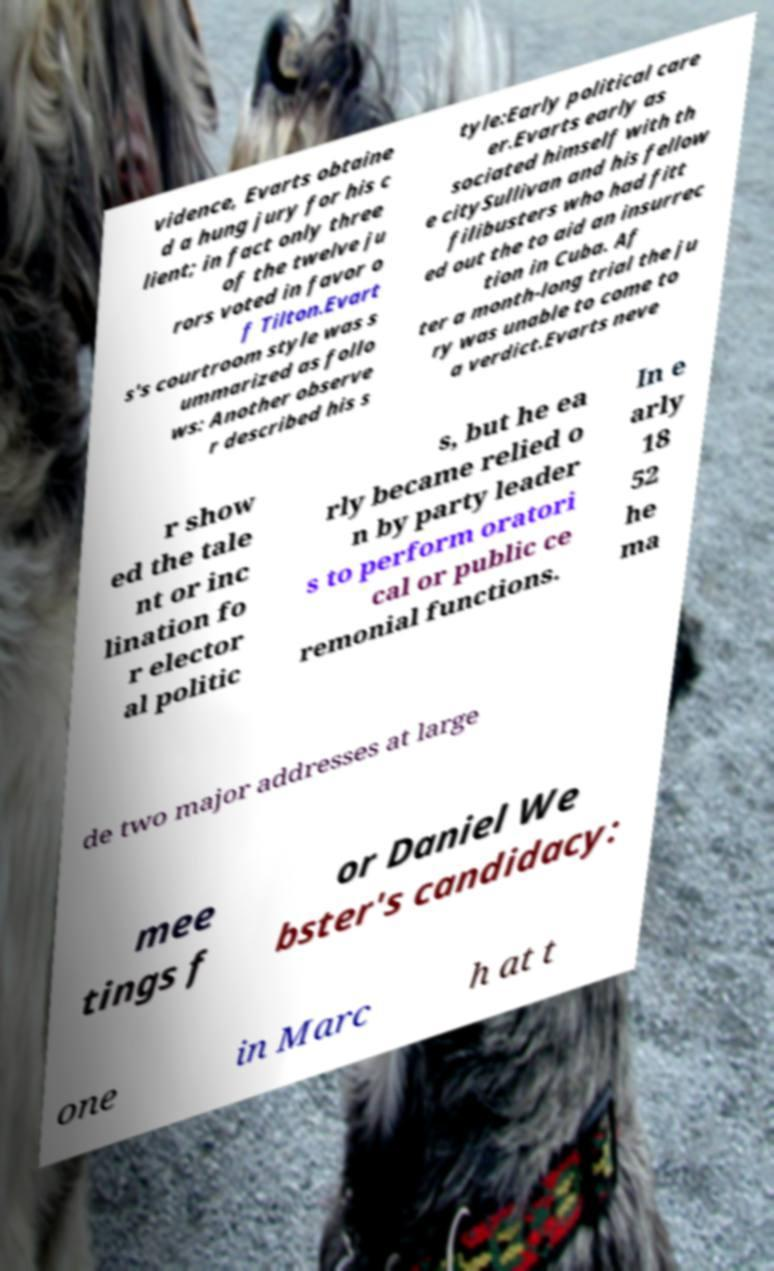Could you assist in decoding the text presented in this image and type it out clearly? vidence, Evarts obtaine d a hung jury for his c lient; in fact only three of the twelve ju rors voted in favor o f Tilton.Evart s's courtroom style was s ummarized as follo ws: Another observe r described his s tyle:Early political care er.Evarts early as sociated himself with th e citySullivan and his fellow filibusters who had fitt ed out the to aid an insurrec tion in Cuba. Af ter a month-long trial the ju ry was unable to come to a verdict.Evarts neve r show ed the tale nt or inc lination fo r elector al politic s, but he ea rly became relied o n by party leader s to perform oratori cal or public ce remonial functions. In e arly 18 52 he ma de two major addresses at large mee tings f or Daniel We bster's candidacy: one in Marc h at t 